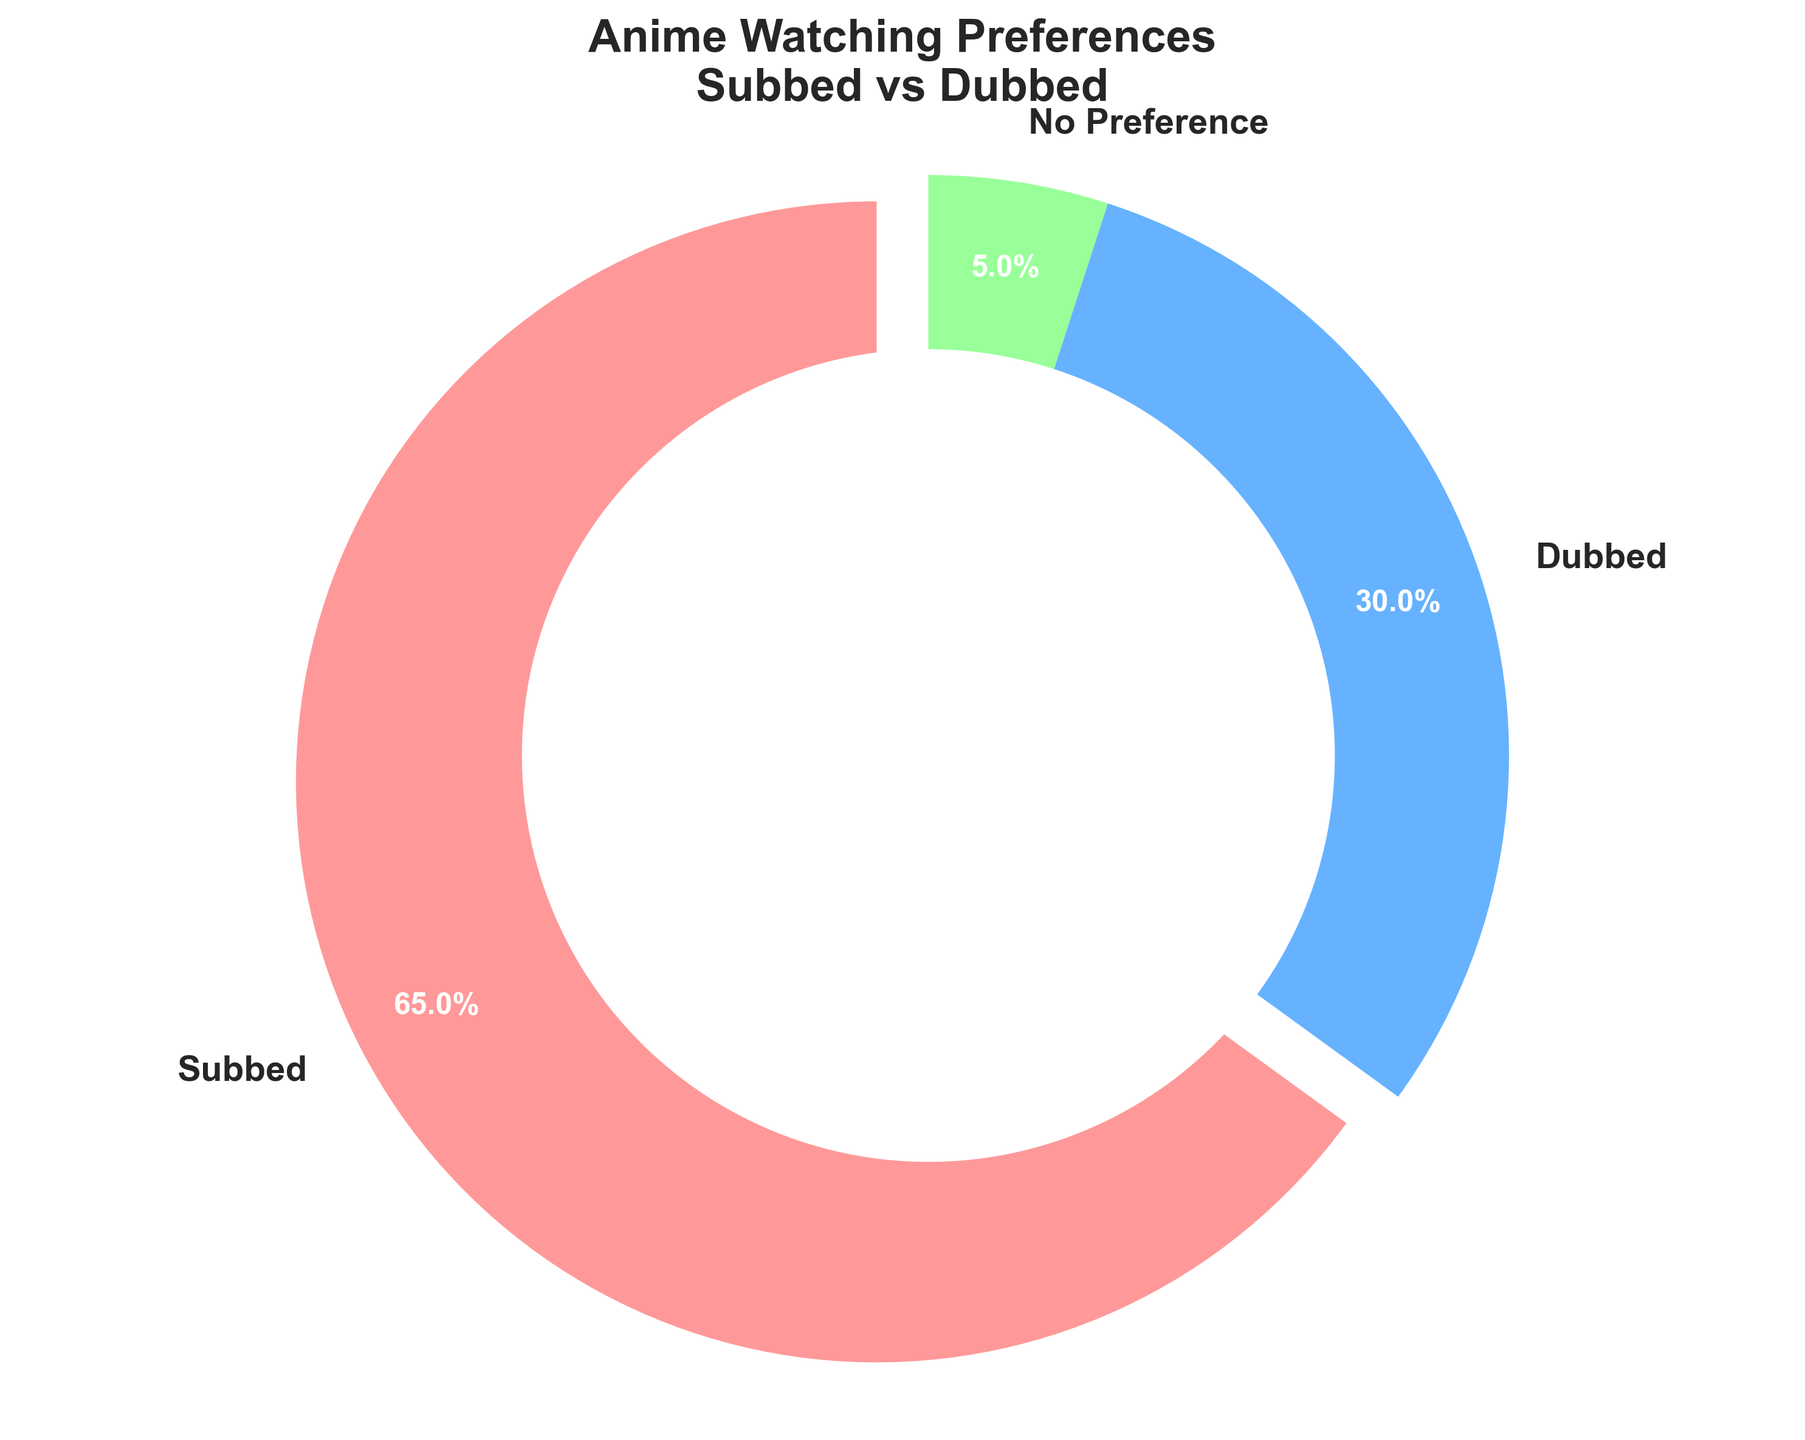What percentage of people prefer subbed anime? Looking at the chart, the subbed section takes up most of the pie. It's labeled with "65%" for subbed. So, 65% of people prefer subbed anime.
Answer: 65% Which preference has the least percentage? The smallest section of the pie chart indicates the "No Preference" category, which is labeled as 5%.
Answer: No Preference What is the total percentage of people who prefer either subbed or dubbed anime? To find this, add the percentages for subbed (65%) and dubbed (30%). 65 + 30 equals 95.
Answer: 95% How much greater is the preference for subbed over dubbed anime? The preference for subbed anime is labeled as 65%, and for dubbed, it’s 30%. Subtract 30 from 65 to find the difference: 65 - 30 = 35.
Answer: 35% What color represents the dubbed anime preference? By describing the visual attributes in the figure, the section for dubbed anime is colored in blue.
Answer: Blue Is the "No Preference" category larger or smaller than the "Dubbed" category? Compared visually, the "No Preference" category is significantly smaller than the "Dubbed" category of the pie chart.
Answer: Smaller What visual features make the subbed section stand out? The subbed section is slightly exploded out from the center (exploded slice) and is colored in pink, making it visually more prominent.
Answer: Exploded slice, pink color 